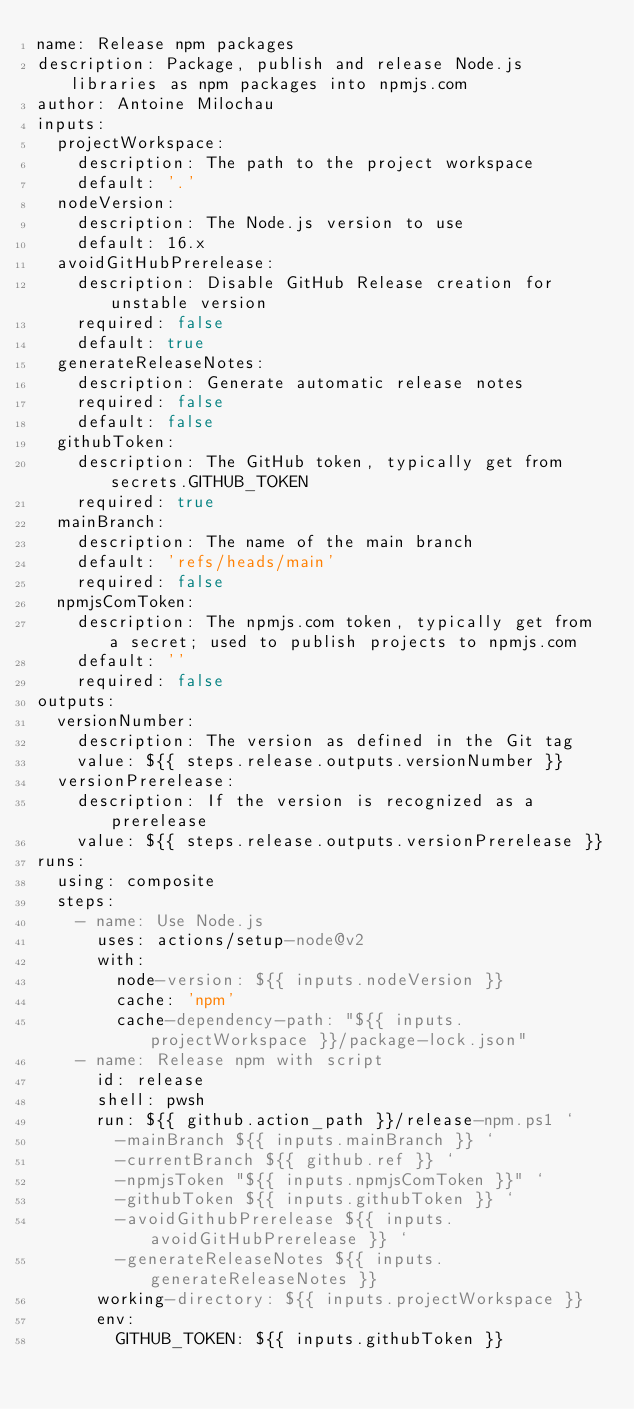Convert code to text. <code><loc_0><loc_0><loc_500><loc_500><_YAML_>name: Release npm packages
description: Package, publish and release Node.js libraries as npm packages into npmjs.com
author: Antoine Milochau
inputs:
  projectWorkspace:
    description: The path to the project workspace
    default: '.'
  nodeVersion:
    description: The Node.js version to use
    default: 16.x
  avoidGitHubPrerelease:
    description: Disable GitHub Release creation for unstable version
    required: false
    default: true
  generateReleaseNotes:
    description: Generate automatic release notes
    required: false
    default: false
  githubToken:
    description: The GitHub token, typically get from secrets.GITHUB_TOKEN
    required: true
  mainBranch:
    description: The name of the main branch
    default: 'refs/heads/main'
    required: false
  npmjsComToken:
    description: The npmjs.com token, typically get from a secret; used to publish projects to npmjs.com
    default: ''
    required: false
outputs:
  versionNumber:
    description: The version as defined in the Git tag
    value: ${{ steps.release.outputs.versionNumber }}
  versionPrerelease:
    description: If the version is recognized as a prerelease
    value: ${{ steps.release.outputs.versionPrerelease }}
runs:
  using: composite
  steps:
    - name: Use Node.js
      uses: actions/setup-node@v2
      with:
        node-version: ${{ inputs.nodeVersion }}
        cache: 'npm'
        cache-dependency-path: "${{ inputs.projectWorkspace }}/package-lock.json"
    - name: Release npm with script
      id: release
      shell: pwsh
      run: ${{ github.action_path }}/release-npm.ps1 `
        -mainBranch ${{ inputs.mainBranch }} `
        -currentBranch ${{ github.ref }} `
        -npmjsToken "${{ inputs.npmjsComToken }}" `
        -githubToken ${{ inputs.githubToken }} `
        -avoidGithubPrerelease ${{ inputs.avoidGitHubPrerelease }} `
        -generateReleaseNotes ${{ inputs.generateReleaseNotes }}
      working-directory: ${{ inputs.projectWorkspace }}
      env:
        GITHUB_TOKEN: ${{ inputs.githubToken }}
</code> 